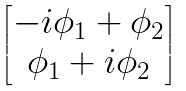Convert formula to latex. <formula><loc_0><loc_0><loc_500><loc_500>\begin{bmatrix} - i \phi _ { 1 } + \phi _ { 2 } \\ \phi _ { 1 } + i \phi _ { 2 } \end{bmatrix}</formula> 